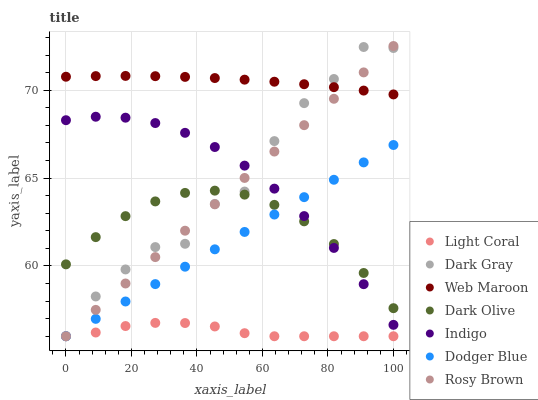Does Light Coral have the minimum area under the curve?
Answer yes or no. Yes. Does Web Maroon have the maximum area under the curve?
Answer yes or no. Yes. Does Rosy Brown have the minimum area under the curve?
Answer yes or no. No. Does Rosy Brown have the maximum area under the curve?
Answer yes or no. No. Is Dodger Blue the smoothest?
Answer yes or no. Yes. Is Dark Gray the roughest?
Answer yes or no. Yes. Is Rosy Brown the smoothest?
Answer yes or no. No. Is Rosy Brown the roughest?
Answer yes or no. No. Does Dark Gray have the lowest value?
Answer yes or no. Yes. Does Indigo have the lowest value?
Answer yes or no. No. Does Rosy Brown have the highest value?
Answer yes or no. Yes. Does Indigo have the highest value?
Answer yes or no. No. Is Dark Olive less than Web Maroon?
Answer yes or no. Yes. Is Web Maroon greater than Dark Olive?
Answer yes or no. Yes. Does Rosy Brown intersect Web Maroon?
Answer yes or no. Yes. Is Rosy Brown less than Web Maroon?
Answer yes or no. No. Is Rosy Brown greater than Web Maroon?
Answer yes or no. No. Does Dark Olive intersect Web Maroon?
Answer yes or no. No. 